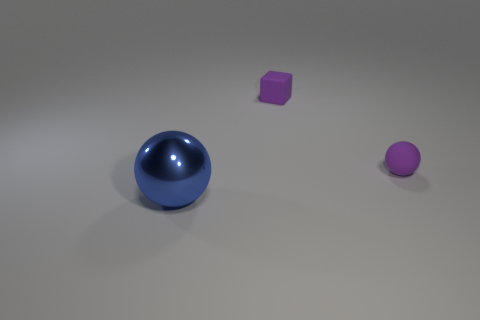Is the color of the tiny matte block the same as the rubber sphere?
Give a very brief answer. Yes. Do the tiny object that is behind the purple ball and the tiny matte ball have the same color?
Offer a very short reply. Yes. The thing that is the same color as the cube is what shape?
Your response must be concise. Sphere. What is the color of the rubber thing that is the same size as the purple matte cube?
Your answer should be very brief. Purple. Is there a small matte thing of the same color as the tiny cube?
Your response must be concise. Yes. What material is the purple sphere?
Provide a short and direct response. Rubber. What number of small spheres are there?
Make the answer very short. 1. Is the color of the sphere to the right of the large blue metallic thing the same as the object left of the small block?
Provide a succinct answer. No. What size is the sphere that is the same color as the tiny rubber cube?
Your response must be concise. Small. How many other things are the same size as the metallic object?
Ensure brevity in your answer.  0. 